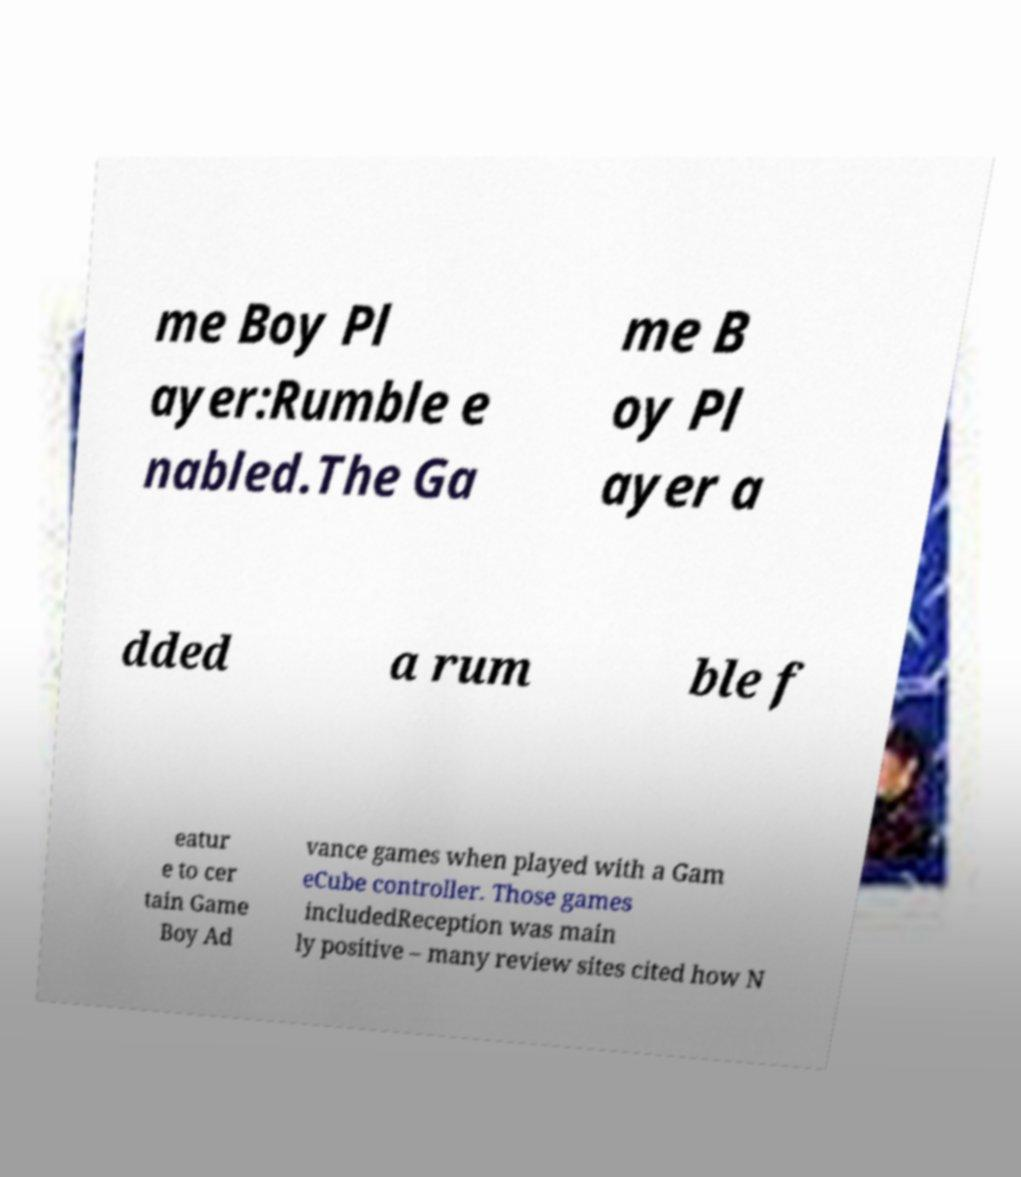Could you assist in decoding the text presented in this image and type it out clearly? me Boy Pl ayer:Rumble e nabled.The Ga me B oy Pl ayer a dded a rum ble f eatur e to cer tain Game Boy Ad vance games when played with a Gam eCube controller. Those games includedReception was main ly positive – many review sites cited how N 